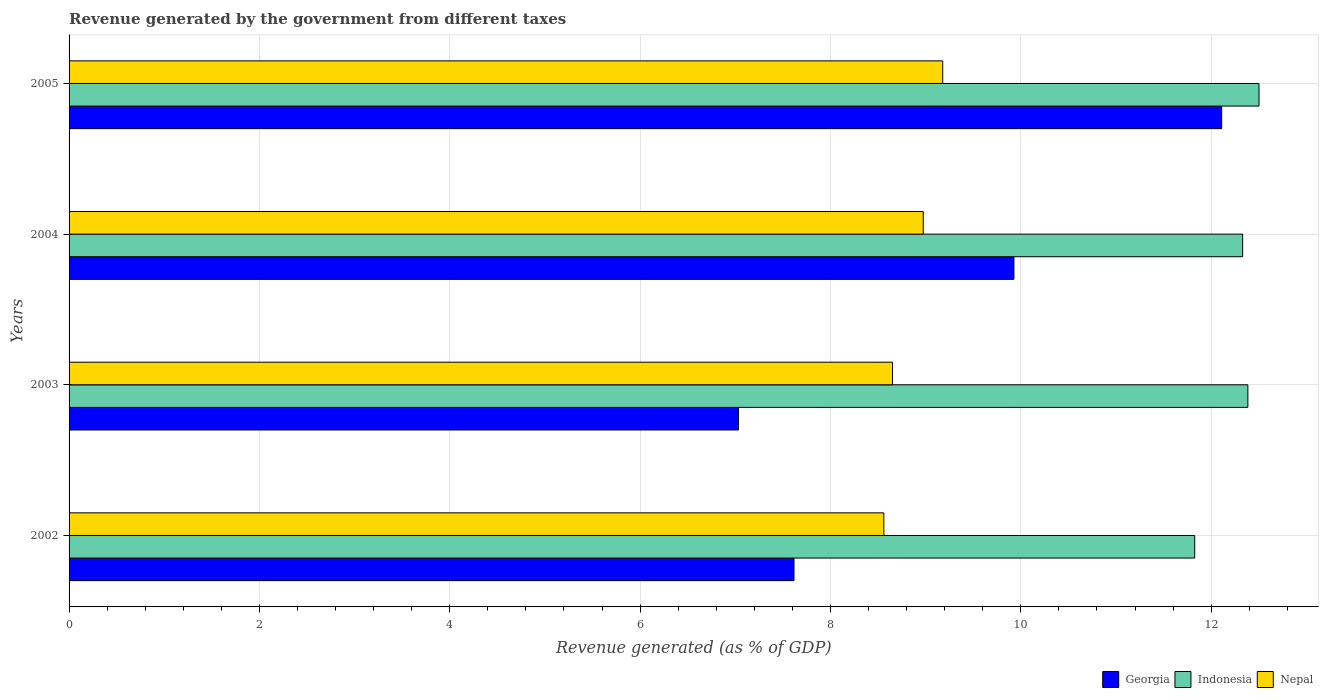Are the number of bars per tick equal to the number of legend labels?
Offer a terse response. Yes. How many bars are there on the 3rd tick from the top?
Offer a very short reply. 3. How many bars are there on the 3rd tick from the bottom?
Provide a succinct answer. 3. What is the label of the 1st group of bars from the top?
Your answer should be very brief. 2005. In how many cases, is the number of bars for a given year not equal to the number of legend labels?
Give a very brief answer. 0. What is the revenue generated by the government in Nepal in 2003?
Make the answer very short. 8.65. Across all years, what is the maximum revenue generated by the government in Nepal?
Make the answer very short. 9.18. Across all years, what is the minimum revenue generated by the government in Nepal?
Offer a terse response. 8.56. In which year was the revenue generated by the government in Georgia maximum?
Provide a short and direct response. 2005. In which year was the revenue generated by the government in Nepal minimum?
Ensure brevity in your answer.  2002. What is the total revenue generated by the government in Nepal in the graph?
Ensure brevity in your answer.  35.37. What is the difference between the revenue generated by the government in Georgia in 2003 and that in 2004?
Give a very brief answer. -2.89. What is the difference between the revenue generated by the government in Indonesia in 2005 and the revenue generated by the government in Nepal in 2002?
Provide a succinct answer. 3.94. What is the average revenue generated by the government in Nepal per year?
Offer a terse response. 8.84. In the year 2005, what is the difference between the revenue generated by the government in Georgia and revenue generated by the government in Indonesia?
Offer a terse response. -0.39. What is the ratio of the revenue generated by the government in Georgia in 2003 to that in 2005?
Give a very brief answer. 0.58. What is the difference between the highest and the second highest revenue generated by the government in Indonesia?
Offer a terse response. 0.12. What is the difference between the highest and the lowest revenue generated by the government in Indonesia?
Offer a very short reply. 0.68. In how many years, is the revenue generated by the government in Indonesia greater than the average revenue generated by the government in Indonesia taken over all years?
Make the answer very short. 3. Is the sum of the revenue generated by the government in Georgia in 2003 and 2005 greater than the maximum revenue generated by the government in Indonesia across all years?
Give a very brief answer. Yes. What does the 3rd bar from the top in 2004 represents?
Offer a very short reply. Georgia. What does the 3rd bar from the bottom in 2003 represents?
Provide a short and direct response. Nepal. Is it the case that in every year, the sum of the revenue generated by the government in Indonesia and revenue generated by the government in Georgia is greater than the revenue generated by the government in Nepal?
Offer a terse response. Yes. Are all the bars in the graph horizontal?
Make the answer very short. Yes. How many years are there in the graph?
Offer a very short reply. 4. Are the values on the major ticks of X-axis written in scientific E-notation?
Ensure brevity in your answer.  No. Does the graph contain grids?
Offer a very short reply. Yes. Where does the legend appear in the graph?
Make the answer very short. Bottom right. How many legend labels are there?
Provide a succinct answer. 3. How are the legend labels stacked?
Offer a terse response. Horizontal. What is the title of the graph?
Keep it short and to the point. Revenue generated by the government from different taxes. What is the label or title of the X-axis?
Your response must be concise. Revenue generated (as % of GDP). What is the Revenue generated (as % of GDP) in Georgia in 2002?
Offer a terse response. 7.62. What is the Revenue generated (as % of GDP) in Indonesia in 2002?
Your answer should be very brief. 11.83. What is the Revenue generated (as % of GDP) of Nepal in 2002?
Ensure brevity in your answer.  8.56. What is the Revenue generated (as % of GDP) of Georgia in 2003?
Your answer should be compact. 7.03. What is the Revenue generated (as % of GDP) of Indonesia in 2003?
Offer a very short reply. 12.39. What is the Revenue generated (as % of GDP) of Nepal in 2003?
Keep it short and to the point. 8.65. What is the Revenue generated (as % of GDP) in Georgia in 2004?
Your answer should be compact. 9.93. What is the Revenue generated (as % of GDP) in Indonesia in 2004?
Provide a short and direct response. 12.33. What is the Revenue generated (as % of GDP) in Nepal in 2004?
Make the answer very short. 8.97. What is the Revenue generated (as % of GDP) of Georgia in 2005?
Provide a succinct answer. 12.11. What is the Revenue generated (as % of GDP) in Indonesia in 2005?
Offer a very short reply. 12.5. What is the Revenue generated (as % of GDP) of Nepal in 2005?
Ensure brevity in your answer.  9.18. Across all years, what is the maximum Revenue generated (as % of GDP) in Georgia?
Your answer should be compact. 12.11. Across all years, what is the maximum Revenue generated (as % of GDP) of Indonesia?
Give a very brief answer. 12.5. Across all years, what is the maximum Revenue generated (as % of GDP) in Nepal?
Your response must be concise. 9.18. Across all years, what is the minimum Revenue generated (as % of GDP) of Georgia?
Make the answer very short. 7.03. Across all years, what is the minimum Revenue generated (as % of GDP) of Indonesia?
Provide a succinct answer. 11.83. Across all years, what is the minimum Revenue generated (as % of GDP) of Nepal?
Provide a short and direct response. 8.56. What is the total Revenue generated (as % of GDP) in Georgia in the graph?
Make the answer very short. 36.69. What is the total Revenue generated (as % of GDP) of Indonesia in the graph?
Keep it short and to the point. 49.05. What is the total Revenue generated (as % of GDP) of Nepal in the graph?
Provide a succinct answer. 35.37. What is the difference between the Revenue generated (as % of GDP) in Georgia in 2002 and that in 2003?
Offer a very short reply. 0.58. What is the difference between the Revenue generated (as % of GDP) in Indonesia in 2002 and that in 2003?
Ensure brevity in your answer.  -0.56. What is the difference between the Revenue generated (as % of GDP) of Nepal in 2002 and that in 2003?
Give a very brief answer. -0.09. What is the difference between the Revenue generated (as % of GDP) of Georgia in 2002 and that in 2004?
Your answer should be very brief. -2.31. What is the difference between the Revenue generated (as % of GDP) in Indonesia in 2002 and that in 2004?
Offer a very short reply. -0.5. What is the difference between the Revenue generated (as % of GDP) of Nepal in 2002 and that in 2004?
Keep it short and to the point. -0.41. What is the difference between the Revenue generated (as % of GDP) of Georgia in 2002 and that in 2005?
Provide a short and direct response. -4.49. What is the difference between the Revenue generated (as % of GDP) of Indonesia in 2002 and that in 2005?
Provide a succinct answer. -0.68. What is the difference between the Revenue generated (as % of GDP) of Nepal in 2002 and that in 2005?
Provide a succinct answer. -0.62. What is the difference between the Revenue generated (as % of GDP) of Georgia in 2003 and that in 2004?
Offer a very short reply. -2.89. What is the difference between the Revenue generated (as % of GDP) in Indonesia in 2003 and that in 2004?
Provide a short and direct response. 0.05. What is the difference between the Revenue generated (as % of GDP) in Nepal in 2003 and that in 2004?
Offer a very short reply. -0.32. What is the difference between the Revenue generated (as % of GDP) of Georgia in 2003 and that in 2005?
Offer a terse response. -5.08. What is the difference between the Revenue generated (as % of GDP) of Indonesia in 2003 and that in 2005?
Ensure brevity in your answer.  -0.12. What is the difference between the Revenue generated (as % of GDP) in Nepal in 2003 and that in 2005?
Your answer should be compact. -0.53. What is the difference between the Revenue generated (as % of GDP) of Georgia in 2004 and that in 2005?
Provide a succinct answer. -2.18. What is the difference between the Revenue generated (as % of GDP) of Indonesia in 2004 and that in 2005?
Your answer should be compact. -0.17. What is the difference between the Revenue generated (as % of GDP) in Nepal in 2004 and that in 2005?
Provide a succinct answer. -0.2. What is the difference between the Revenue generated (as % of GDP) in Georgia in 2002 and the Revenue generated (as % of GDP) in Indonesia in 2003?
Offer a terse response. -4.77. What is the difference between the Revenue generated (as % of GDP) of Georgia in 2002 and the Revenue generated (as % of GDP) of Nepal in 2003?
Your answer should be compact. -1.04. What is the difference between the Revenue generated (as % of GDP) of Indonesia in 2002 and the Revenue generated (as % of GDP) of Nepal in 2003?
Your answer should be compact. 3.18. What is the difference between the Revenue generated (as % of GDP) in Georgia in 2002 and the Revenue generated (as % of GDP) in Indonesia in 2004?
Offer a terse response. -4.71. What is the difference between the Revenue generated (as % of GDP) in Georgia in 2002 and the Revenue generated (as % of GDP) in Nepal in 2004?
Offer a very short reply. -1.36. What is the difference between the Revenue generated (as % of GDP) of Indonesia in 2002 and the Revenue generated (as % of GDP) of Nepal in 2004?
Give a very brief answer. 2.85. What is the difference between the Revenue generated (as % of GDP) in Georgia in 2002 and the Revenue generated (as % of GDP) in Indonesia in 2005?
Your answer should be compact. -4.89. What is the difference between the Revenue generated (as % of GDP) in Georgia in 2002 and the Revenue generated (as % of GDP) in Nepal in 2005?
Your answer should be very brief. -1.56. What is the difference between the Revenue generated (as % of GDP) in Indonesia in 2002 and the Revenue generated (as % of GDP) in Nepal in 2005?
Ensure brevity in your answer.  2.65. What is the difference between the Revenue generated (as % of GDP) of Georgia in 2003 and the Revenue generated (as % of GDP) of Indonesia in 2004?
Your answer should be compact. -5.3. What is the difference between the Revenue generated (as % of GDP) in Georgia in 2003 and the Revenue generated (as % of GDP) in Nepal in 2004?
Your response must be concise. -1.94. What is the difference between the Revenue generated (as % of GDP) of Indonesia in 2003 and the Revenue generated (as % of GDP) of Nepal in 2004?
Your answer should be compact. 3.41. What is the difference between the Revenue generated (as % of GDP) in Georgia in 2003 and the Revenue generated (as % of GDP) in Indonesia in 2005?
Your answer should be compact. -5.47. What is the difference between the Revenue generated (as % of GDP) in Georgia in 2003 and the Revenue generated (as % of GDP) in Nepal in 2005?
Give a very brief answer. -2.15. What is the difference between the Revenue generated (as % of GDP) in Indonesia in 2003 and the Revenue generated (as % of GDP) in Nepal in 2005?
Your answer should be very brief. 3.21. What is the difference between the Revenue generated (as % of GDP) in Georgia in 2004 and the Revenue generated (as % of GDP) in Indonesia in 2005?
Your answer should be compact. -2.57. What is the difference between the Revenue generated (as % of GDP) in Georgia in 2004 and the Revenue generated (as % of GDP) in Nepal in 2005?
Your response must be concise. 0.75. What is the difference between the Revenue generated (as % of GDP) in Indonesia in 2004 and the Revenue generated (as % of GDP) in Nepal in 2005?
Offer a very short reply. 3.15. What is the average Revenue generated (as % of GDP) of Georgia per year?
Your answer should be very brief. 9.17. What is the average Revenue generated (as % of GDP) in Indonesia per year?
Give a very brief answer. 12.26. What is the average Revenue generated (as % of GDP) in Nepal per year?
Your response must be concise. 8.84. In the year 2002, what is the difference between the Revenue generated (as % of GDP) of Georgia and Revenue generated (as % of GDP) of Indonesia?
Your answer should be very brief. -4.21. In the year 2002, what is the difference between the Revenue generated (as % of GDP) in Georgia and Revenue generated (as % of GDP) in Nepal?
Your answer should be compact. -0.94. In the year 2002, what is the difference between the Revenue generated (as % of GDP) in Indonesia and Revenue generated (as % of GDP) in Nepal?
Provide a short and direct response. 3.27. In the year 2003, what is the difference between the Revenue generated (as % of GDP) of Georgia and Revenue generated (as % of GDP) of Indonesia?
Provide a short and direct response. -5.35. In the year 2003, what is the difference between the Revenue generated (as % of GDP) in Georgia and Revenue generated (as % of GDP) in Nepal?
Offer a very short reply. -1.62. In the year 2003, what is the difference between the Revenue generated (as % of GDP) of Indonesia and Revenue generated (as % of GDP) of Nepal?
Ensure brevity in your answer.  3.73. In the year 2004, what is the difference between the Revenue generated (as % of GDP) of Georgia and Revenue generated (as % of GDP) of Indonesia?
Ensure brevity in your answer.  -2.4. In the year 2004, what is the difference between the Revenue generated (as % of GDP) in Georgia and Revenue generated (as % of GDP) in Nepal?
Provide a short and direct response. 0.95. In the year 2004, what is the difference between the Revenue generated (as % of GDP) in Indonesia and Revenue generated (as % of GDP) in Nepal?
Provide a succinct answer. 3.36. In the year 2005, what is the difference between the Revenue generated (as % of GDP) in Georgia and Revenue generated (as % of GDP) in Indonesia?
Offer a terse response. -0.39. In the year 2005, what is the difference between the Revenue generated (as % of GDP) in Georgia and Revenue generated (as % of GDP) in Nepal?
Offer a very short reply. 2.93. In the year 2005, what is the difference between the Revenue generated (as % of GDP) in Indonesia and Revenue generated (as % of GDP) in Nepal?
Provide a succinct answer. 3.32. What is the ratio of the Revenue generated (as % of GDP) of Georgia in 2002 to that in 2003?
Ensure brevity in your answer.  1.08. What is the ratio of the Revenue generated (as % of GDP) in Indonesia in 2002 to that in 2003?
Your answer should be compact. 0.95. What is the ratio of the Revenue generated (as % of GDP) in Nepal in 2002 to that in 2003?
Give a very brief answer. 0.99. What is the ratio of the Revenue generated (as % of GDP) in Georgia in 2002 to that in 2004?
Ensure brevity in your answer.  0.77. What is the ratio of the Revenue generated (as % of GDP) of Indonesia in 2002 to that in 2004?
Your response must be concise. 0.96. What is the ratio of the Revenue generated (as % of GDP) in Nepal in 2002 to that in 2004?
Provide a short and direct response. 0.95. What is the ratio of the Revenue generated (as % of GDP) of Georgia in 2002 to that in 2005?
Provide a succinct answer. 0.63. What is the ratio of the Revenue generated (as % of GDP) in Indonesia in 2002 to that in 2005?
Your response must be concise. 0.95. What is the ratio of the Revenue generated (as % of GDP) in Nepal in 2002 to that in 2005?
Provide a succinct answer. 0.93. What is the ratio of the Revenue generated (as % of GDP) in Georgia in 2003 to that in 2004?
Provide a short and direct response. 0.71. What is the ratio of the Revenue generated (as % of GDP) in Indonesia in 2003 to that in 2004?
Your answer should be compact. 1. What is the ratio of the Revenue generated (as % of GDP) in Nepal in 2003 to that in 2004?
Give a very brief answer. 0.96. What is the ratio of the Revenue generated (as % of GDP) of Georgia in 2003 to that in 2005?
Give a very brief answer. 0.58. What is the ratio of the Revenue generated (as % of GDP) in Indonesia in 2003 to that in 2005?
Give a very brief answer. 0.99. What is the ratio of the Revenue generated (as % of GDP) of Nepal in 2003 to that in 2005?
Provide a short and direct response. 0.94. What is the ratio of the Revenue generated (as % of GDP) of Georgia in 2004 to that in 2005?
Offer a very short reply. 0.82. What is the ratio of the Revenue generated (as % of GDP) in Indonesia in 2004 to that in 2005?
Provide a succinct answer. 0.99. What is the ratio of the Revenue generated (as % of GDP) of Nepal in 2004 to that in 2005?
Give a very brief answer. 0.98. What is the difference between the highest and the second highest Revenue generated (as % of GDP) in Georgia?
Offer a terse response. 2.18. What is the difference between the highest and the second highest Revenue generated (as % of GDP) in Indonesia?
Keep it short and to the point. 0.12. What is the difference between the highest and the second highest Revenue generated (as % of GDP) of Nepal?
Make the answer very short. 0.2. What is the difference between the highest and the lowest Revenue generated (as % of GDP) of Georgia?
Keep it short and to the point. 5.08. What is the difference between the highest and the lowest Revenue generated (as % of GDP) in Indonesia?
Ensure brevity in your answer.  0.68. What is the difference between the highest and the lowest Revenue generated (as % of GDP) of Nepal?
Your response must be concise. 0.62. 